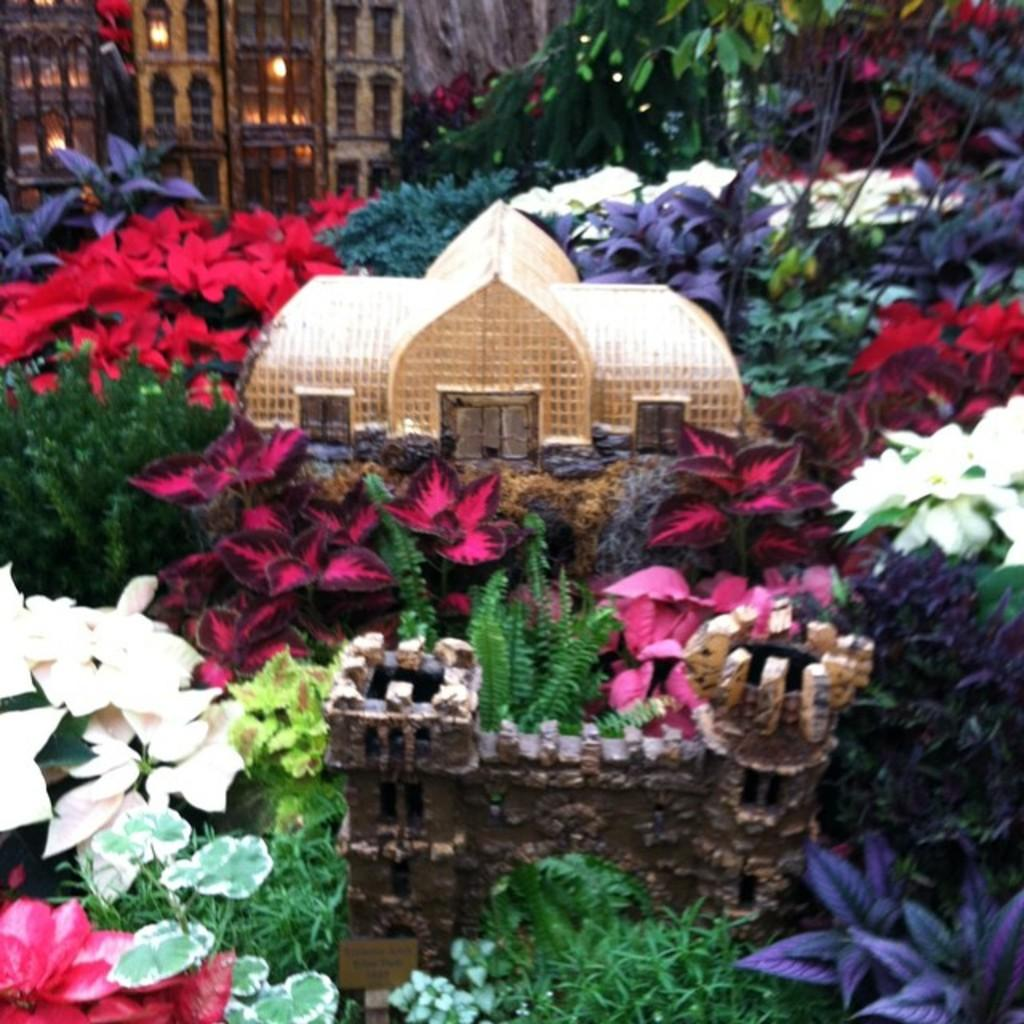What type of plants can be seen in the image? There are colorful plants in the image. What structure is located in the middle of the image? There is a small castle in the middle of the image. What can be seen in the background of the image? There is a house in the background of the image. Can you see a giraffe in the image? No, there is no giraffe present in the image. What type of brake is used on the small castle in the image? There is no mention of a brake in the image, as it features colorful plants, a small castle, and a house in the background. 